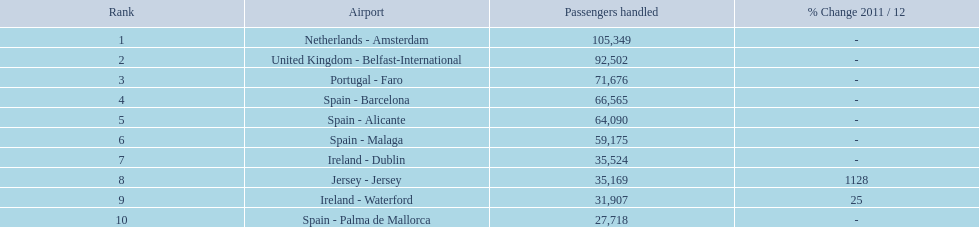What are all the airports in the top 10 busiest routes to and from london southend airport? Netherlands - Amsterdam, United Kingdom - Belfast-International, Portugal - Faro, Spain - Barcelona, Spain - Alicante, Spain - Malaga, Ireland - Dublin, Jersey - Jersey, Ireland - Waterford, Spain - Palma de Mallorca. Which airports are located in portugal? Portugal - Faro. 